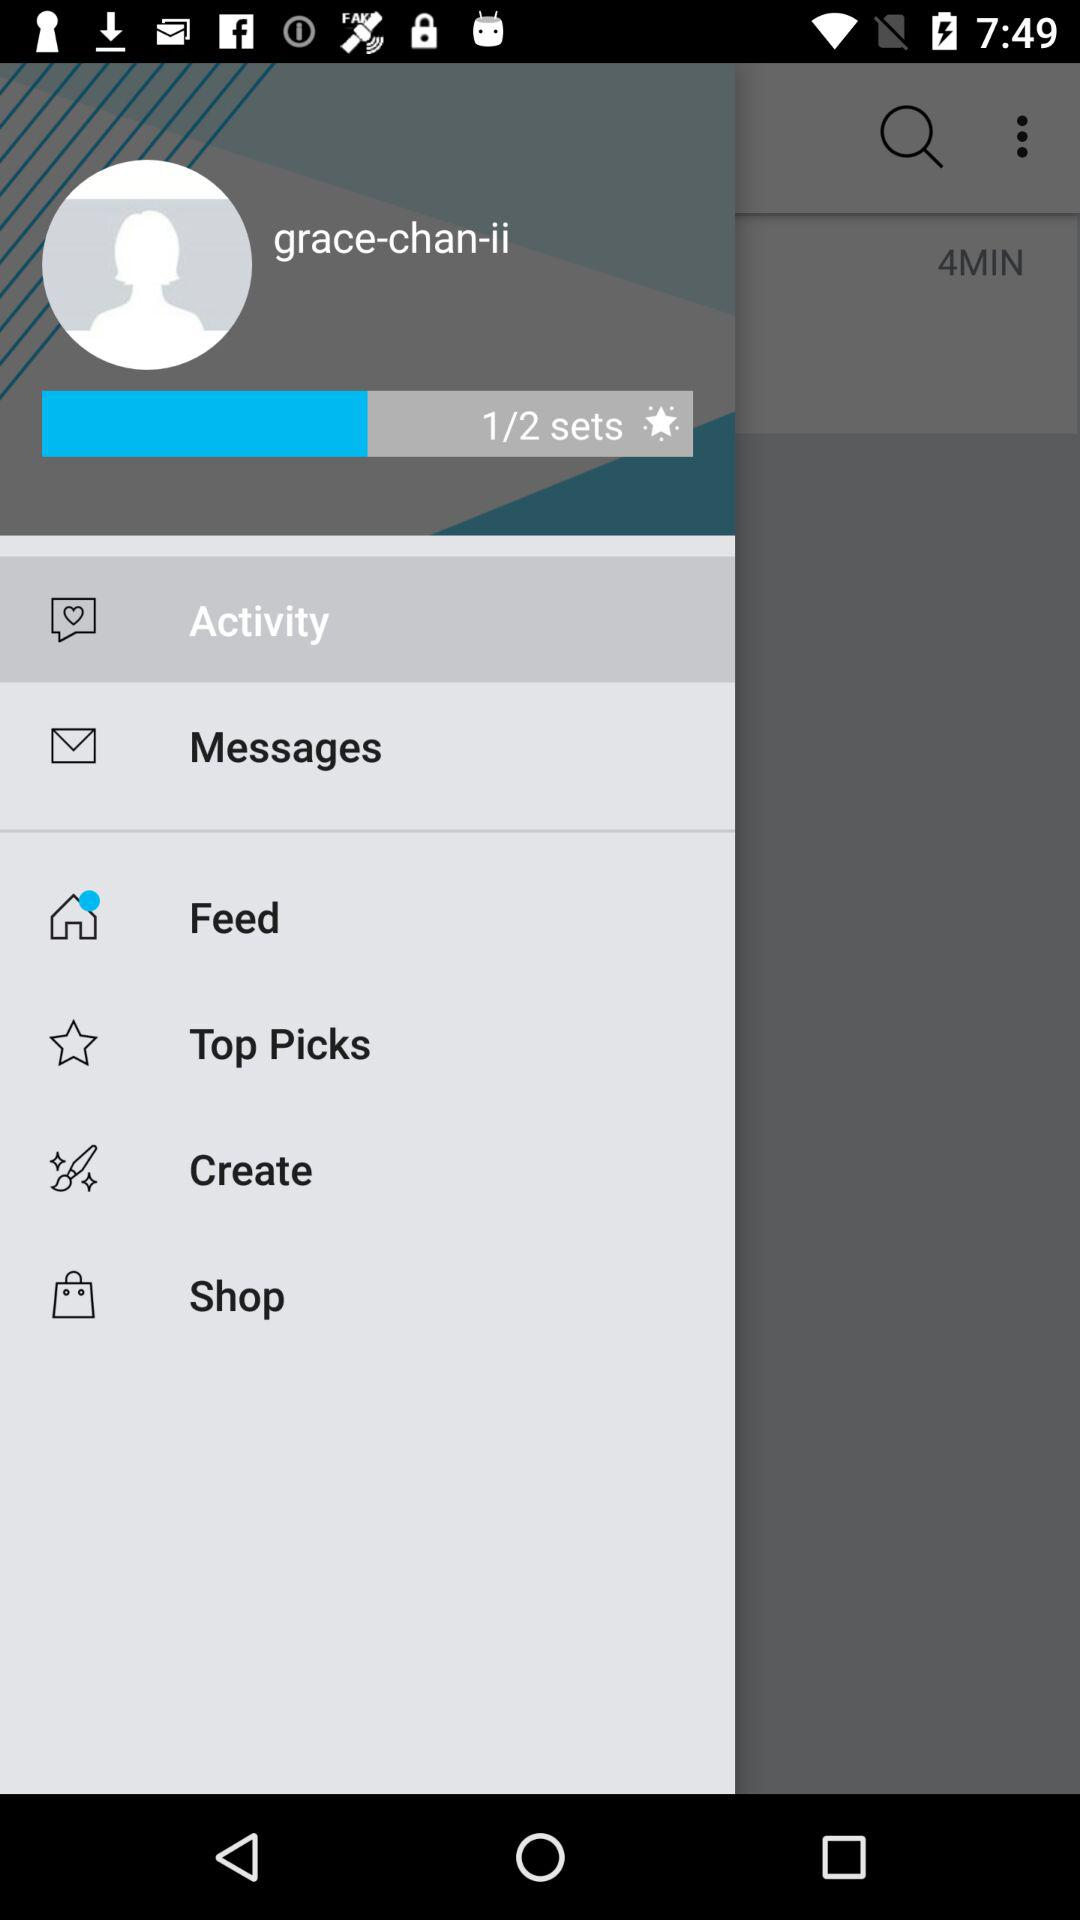How many sets are available? There are 2 available sets. 